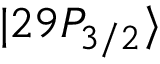Convert formula to latex. <formula><loc_0><loc_0><loc_500><loc_500>| 2 9 P _ { 3 / 2 } \rangle</formula> 